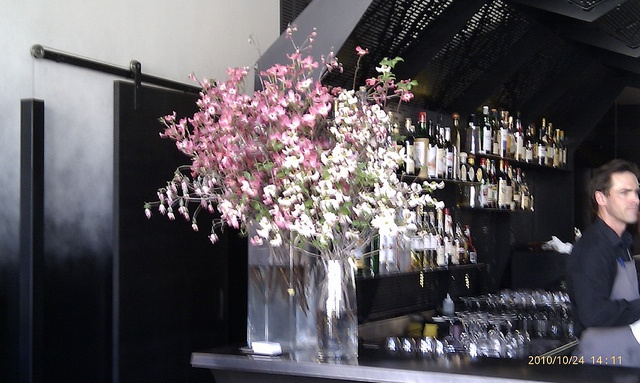Describe the objects in this image and their specific colors. I can see refrigerator in lightgray, black, gray, and darkgray tones, people in lightgray, black, gray, and lightpink tones, bottle in lightgray, black, gray, and darkgray tones, vase in lightgray, gray, darkgray, and white tones, and vase in lightgray, gray, white, and darkgray tones in this image. 